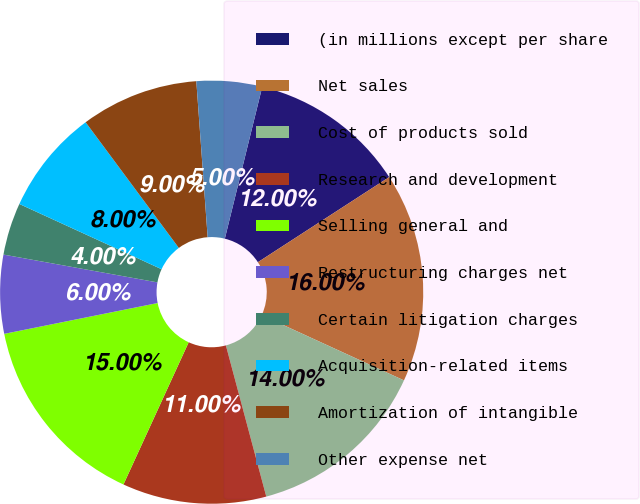Convert chart to OTSL. <chart><loc_0><loc_0><loc_500><loc_500><pie_chart><fcel>(in millions except per share<fcel>Net sales<fcel>Cost of products sold<fcel>Research and development<fcel>Selling general and<fcel>Restructuring charges net<fcel>Certain litigation charges<fcel>Acquisition-related items<fcel>Amortization of intangible<fcel>Other expense net<nl><fcel>12.0%<fcel>16.0%<fcel>14.0%<fcel>11.0%<fcel>15.0%<fcel>6.0%<fcel>4.0%<fcel>8.0%<fcel>9.0%<fcel>5.0%<nl></chart> 